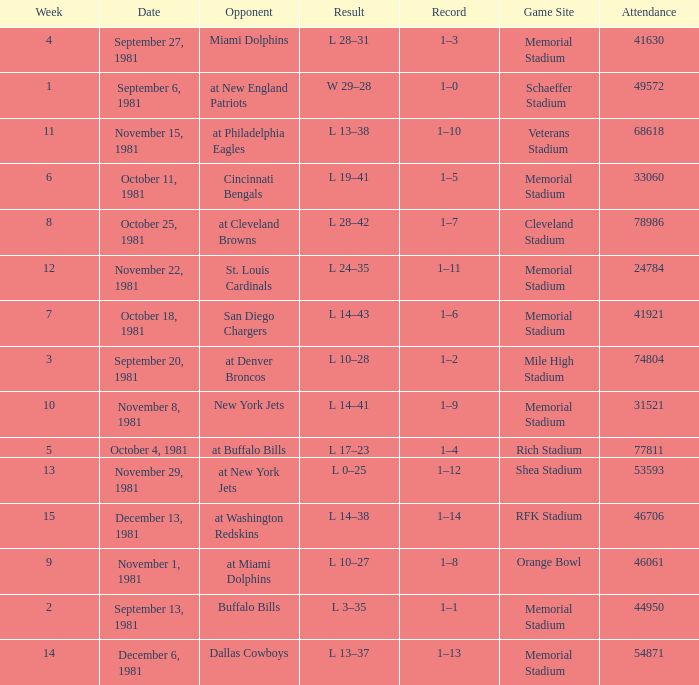When it is October 18, 1981 where is the game site? Memorial Stadium. 